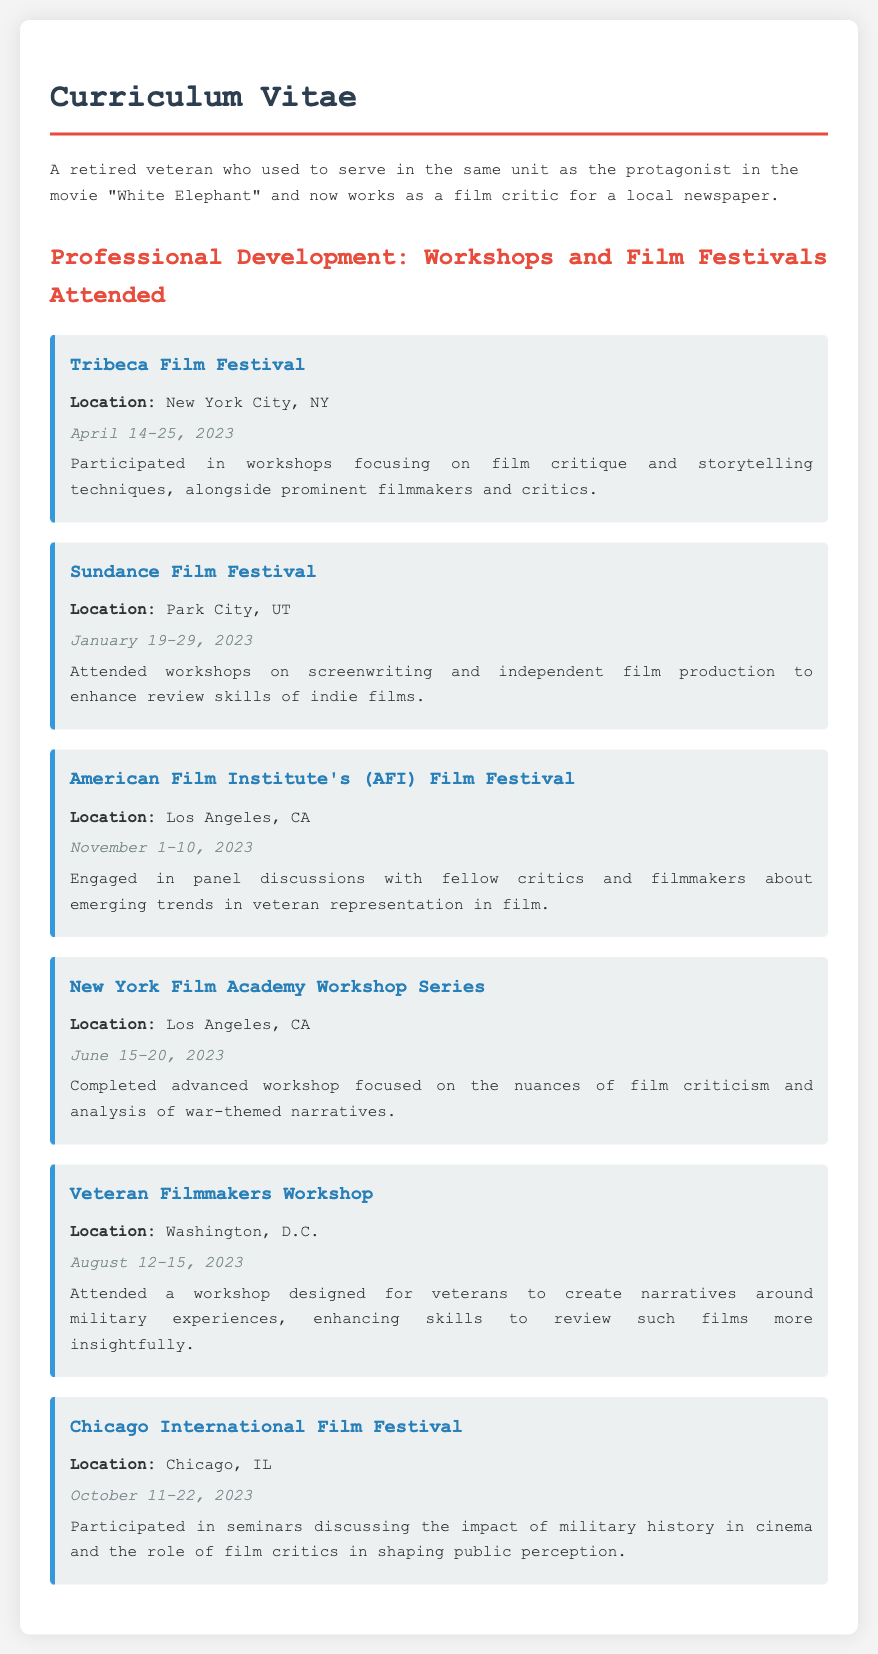What is the location of the Tribeca Film Festival? The location is explicitly stated in the document as New York City, NY.
Answer: New York City, NY What date did the Sundance Film Festival occur? The specific date for the Sundance Film Festival is mentioned in the document as January 19-29, 2023.
Answer: January 19-29, 2023 Which workshop focused on war-themed narratives? Information in the document specifies the New York Film Academy Workshop Series as focusing on the nuances of film criticism related to war-themed narratives.
Answer: New York Film Academy Workshop Series How many events are listed in the professional development section? Counting the events listed in the document shows that there are six distinct events mentioned.
Answer: 6 What was the main focus of the Veteran Filmmakers Workshop? The document describes that the workshop was designed for veterans to create narratives around military experiences.
Answer: Military experiences What is the emphasis of the American Film Institute's Film Festival discussions? The document indicates that panel discussions centered around emerging trends in veteran representation in film.
Answer: Veteran representation in film Where was the Chicago International Film Festival held? The location of the Chicago International Film Festival is specifically given as Chicago, IL in the document.
Answer: Chicago, IL During which month did the New York Film Academy Workshop Series take place? The document provides the date of the workshop as June 15-20, 2023, indicating it took place in June.
Answer: June What type of workshops were highlighted at the Tribeca Film Festival? The document mentions that workshops focused on film critique and storytelling techniques were highlighted.
Answer: Film critique and storytelling techniques 